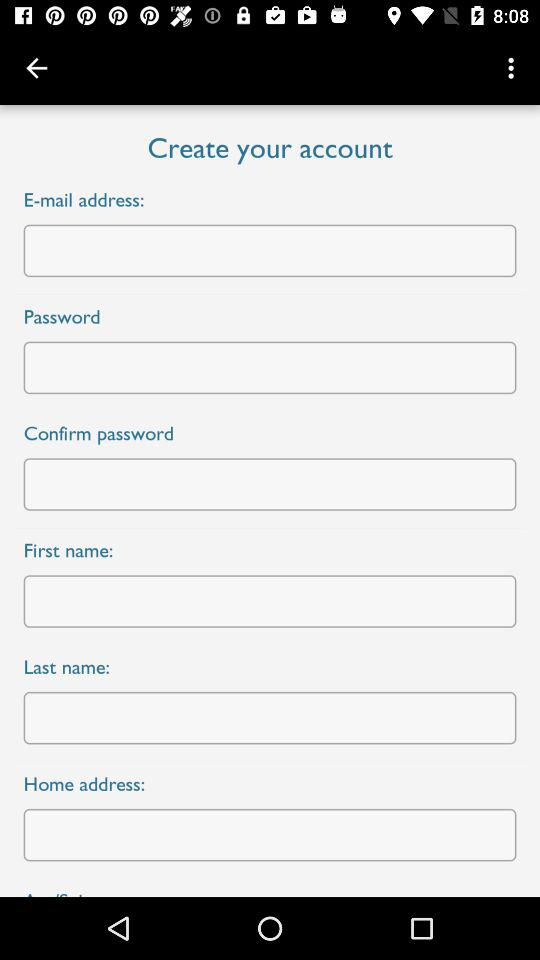How many fields are required for creating a new account?
Answer the question using a single word or phrase. 6 